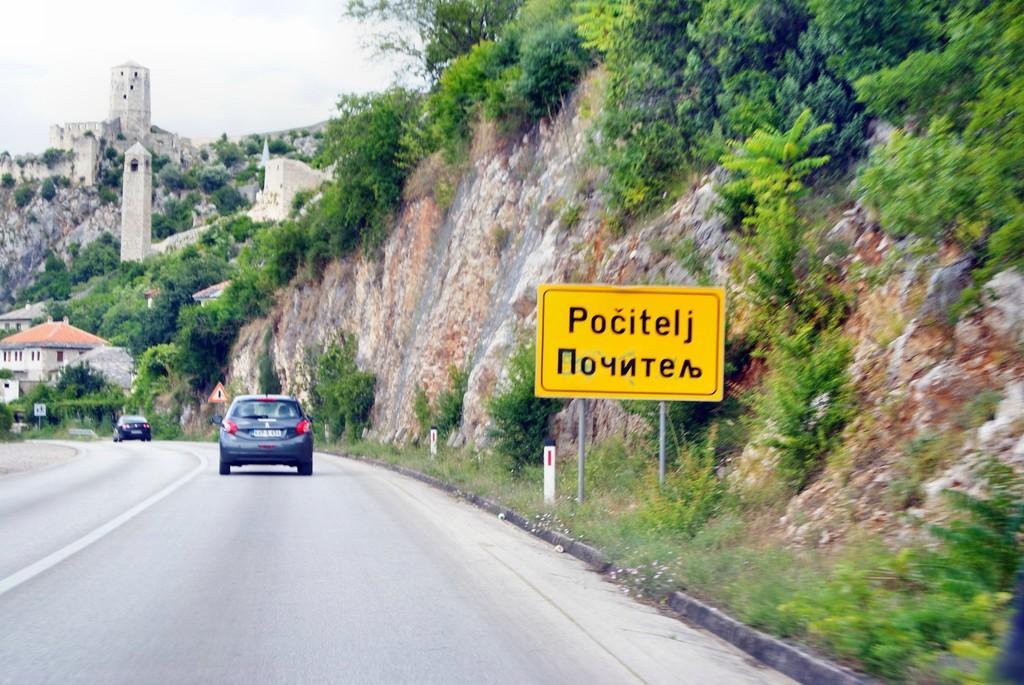Can you describe this image briefly? There are cars on the road as we can see at the bottom of this image. We can see trees on the mountains and a board present on the right side of this image. There are houses on the left side of this image and the sky is in the background. 